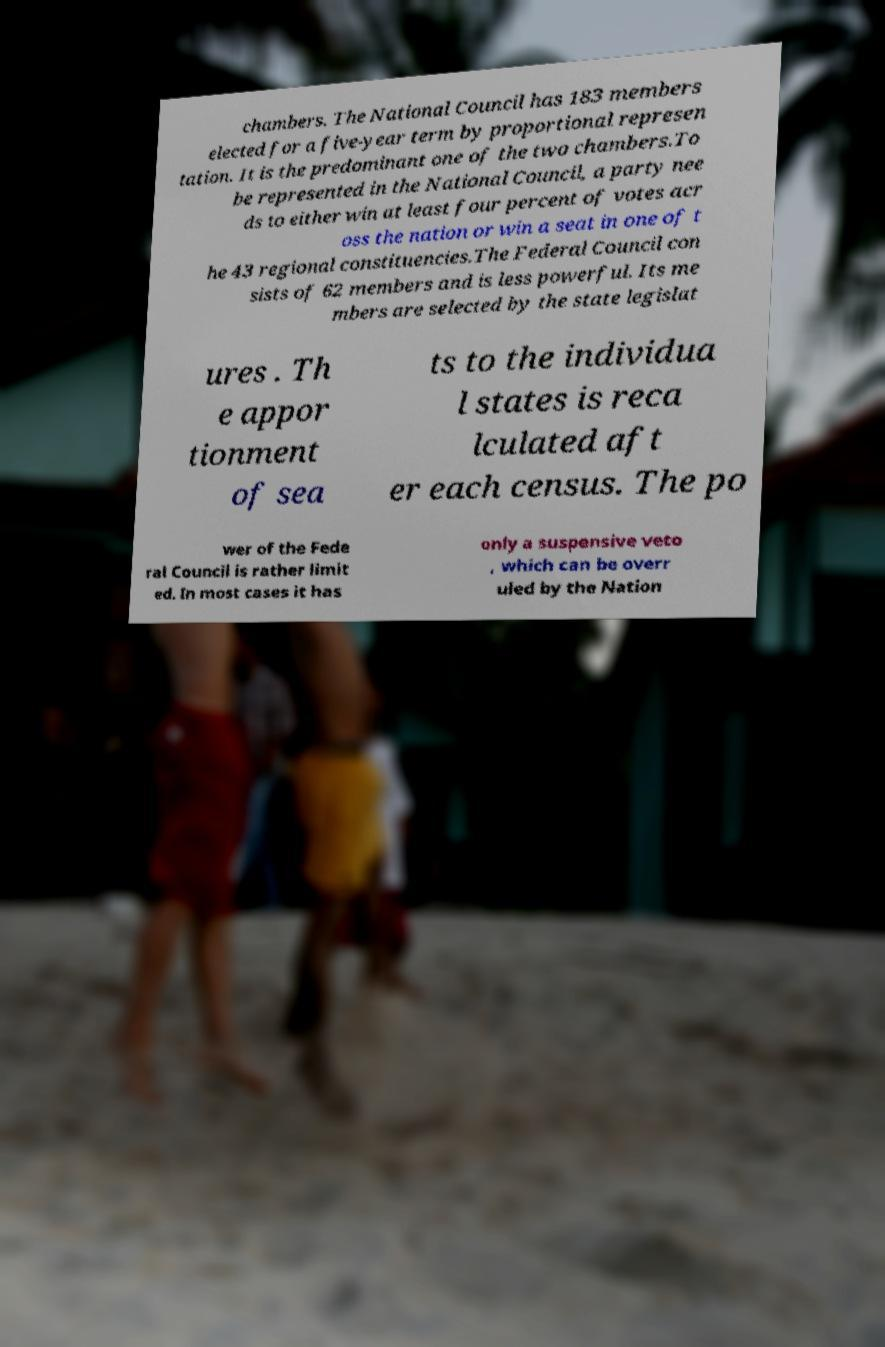Can you accurately transcribe the text from the provided image for me? chambers. The National Council has 183 members elected for a five-year term by proportional represen tation. It is the predominant one of the two chambers.To be represented in the National Council, a party nee ds to either win at least four percent of votes acr oss the nation or win a seat in one of t he 43 regional constituencies.The Federal Council con sists of 62 members and is less powerful. Its me mbers are selected by the state legislat ures . Th e appor tionment of sea ts to the individua l states is reca lculated aft er each census. The po wer of the Fede ral Council is rather limit ed. In most cases it has only a suspensive veto , which can be overr uled by the Nation 